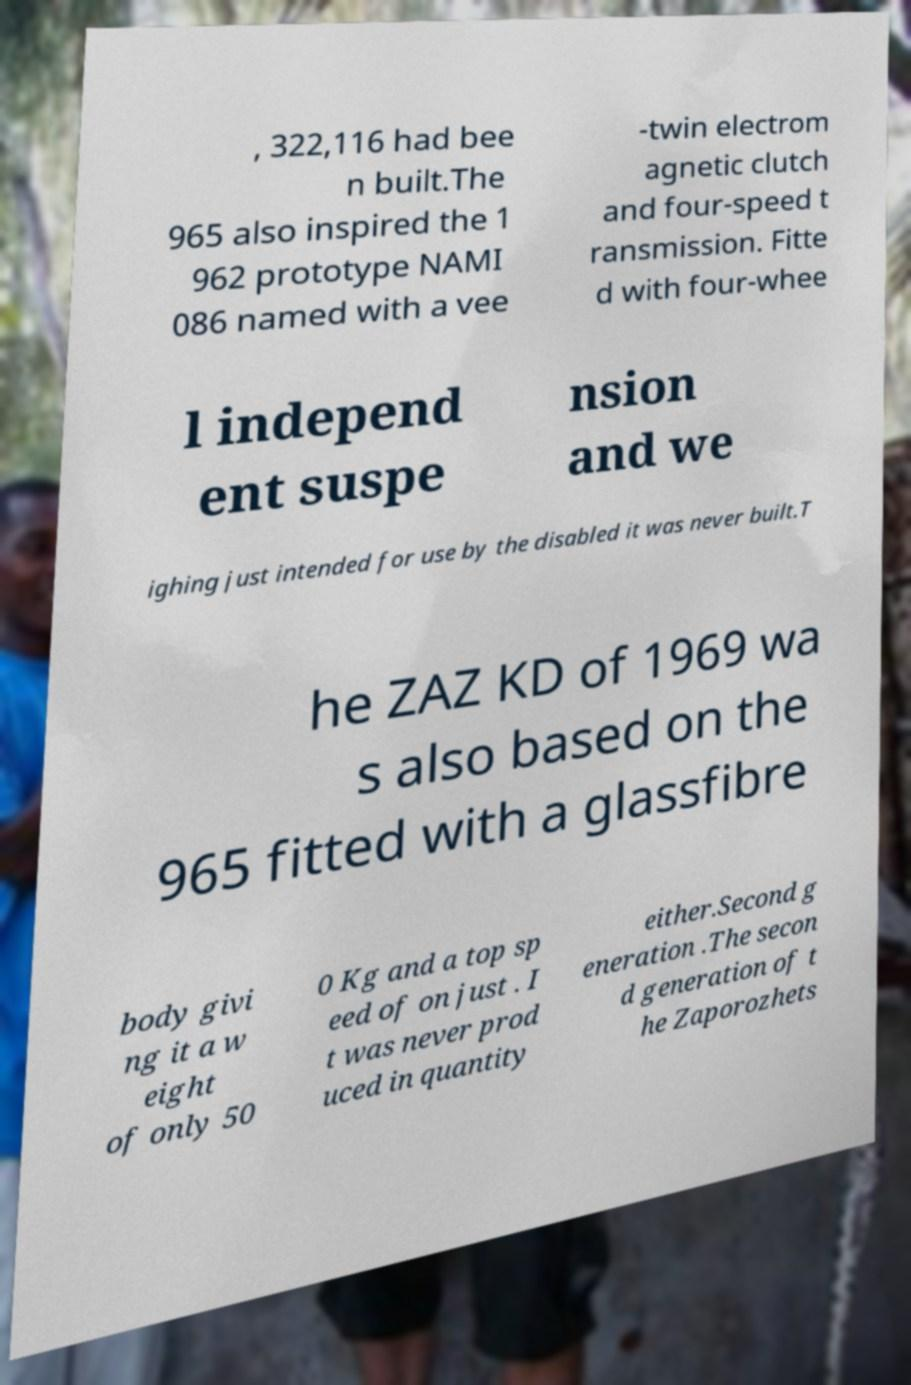Please read and relay the text visible in this image. What does it say? , 322,116 had bee n built.The 965 also inspired the 1 962 prototype NAMI 086 named with a vee -twin electrom agnetic clutch and four-speed t ransmission. Fitte d with four-whee l independ ent suspe nsion and we ighing just intended for use by the disabled it was never built.T he ZAZ KD of 1969 wa s also based on the 965 fitted with a glassfibre body givi ng it a w eight of only 50 0 Kg and a top sp eed of on just . I t was never prod uced in quantity either.Second g eneration .The secon d generation of t he Zaporozhets 